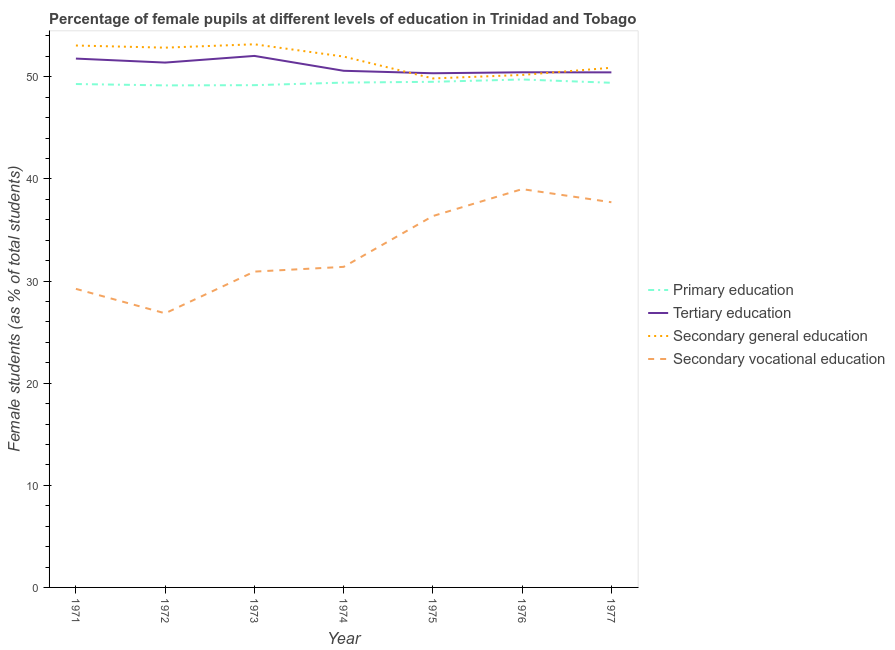Does the line corresponding to percentage of female students in primary education intersect with the line corresponding to percentage of female students in secondary education?
Provide a short and direct response. No. Is the number of lines equal to the number of legend labels?
Your response must be concise. Yes. What is the percentage of female students in secondary education in 1973?
Keep it short and to the point. 53.18. Across all years, what is the minimum percentage of female students in secondary vocational education?
Provide a short and direct response. 26.84. In which year was the percentage of female students in secondary vocational education maximum?
Make the answer very short. 1976. In which year was the percentage of female students in primary education minimum?
Give a very brief answer. 1972. What is the total percentage of female students in primary education in the graph?
Your response must be concise. 345.71. What is the difference between the percentage of female students in tertiary education in 1973 and that in 1977?
Your answer should be compact. 1.61. What is the difference between the percentage of female students in secondary vocational education in 1971 and the percentage of female students in tertiary education in 1974?
Your answer should be very brief. -21.35. What is the average percentage of female students in tertiary education per year?
Ensure brevity in your answer.  51. In the year 1977, what is the difference between the percentage of female students in tertiary education and percentage of female students in secondary vocational education?
Your answer should be very brief. 12.72. In how many years, is the percentage of female students in secondary education greater than 48 %?
Give a very brief answer. 7. What is the ratio of the percentage of female students in secondary vocational education in 1972 to that in 1977?
Make the answer very short. 0.71. What is the difference between the highest and the second highest percentage of female students in tertiary education?
Provide a short and direct response. 0.26. What is the difference between the highest and the lowest percentage of female students in tertiary education?
Your answer should be compact. 1.7. Does the percentage of female students in primary education monotonically increase over the years?
Your response must be concise. No. Is the percentage of female students in secondary vocational education strictly greater than the percentage of female students in tertiary education over the years?
Give a very brief answer. No. How many lines are there?
Offer a terse response. 4. How many years are there in the graph?
Your answer should be very brief. 7. What is the difference between two consecutive major ticks on the Y-axis?
Keep it short and to the point. 10. Are the values on the major ticks of Y-axis written in scientific E-notation?
Make the answer very short. No. Where does the legend appear in the graph?
Make the answer very short. Center right. What is the title of the graph?
Your response must be concise. Percentage of female pupils at different levels of education in Trinidad and Tobago. What is the label or title of the Y-axis?
Ensure brevity in your answer.  Female students (as % of total students). What is the Female students (as % of total students) in Primary education in 1971?
Offer a very short reply. 49.29. What is the Female students (as % of total students) of Tertiary education in 1971?
Keep it short and to the point. 51.78. What is the Female students (as % of total students) of Secondary general education in 1971?
Offer a very short reply. 53.06. What is the Female students (as % of total students) of Secondary vocational education in 1971?
Your response must be concise. 29.23. What is the Female students (as % of total students) of Primary education in 1972?
Offer a terse response. 49.16. What is the Female students (as % of total students) in Tertiary education in 1972?
Your answer should be very brief. 51.39. What is the Female students (as % of total students) of Secondary general education in 1972?
Keep it short and to the point. 52.85. What is the Female students (as % of total students) of Secondary vocational education in 1972?
Your answer should be compact. 26.84. What is the Female students (as % of total students) of Primary education in 1973?
Offer a terse response. 49.18. What is the Female students (as % of total students) in Tertiary education in 1973?
Your answer should be compact. 52.04. What is the Female students (as % of total students) of Secondary general education in 1973?
Provide a short and direct response. 53.18. What is the Female students (as % of total students) in Secondary vocational education in 1973?
Provide a short and direct response. 30.92. What is the Female students (as % of total students) of Primary education in 1974?
Make the answer very short. 49.43. What is the Female students (as % of total students) in Tertiary education in 1974?
Offer a very short reply. 50.59. What is the Female students (as % of total students) of Secondary general education in 1974?
Offer a very short reply. 51.98. What is the Female students (as % of total students) in Secondary vocational education in 1974?
Keep it short and to the point. 31.39. What is the Female students (as % of total students) in Primary education in 1975?
Provide a succinct answer. 49.51. What is the Female students (as % of total students) in Tertiary education in 1975?
Ensure brevity in your answer.  50.34. What is the Female students (as % of total students) in Secondary general education in 1975?
Give a very brief answer. 49.84. What is the Female students (as % of total students) in Secondary vocational education in 1975?
Make the answer very short. 36.36. What is the Female students (as % of total students) in Primary education in 1976?
Offer a terse response. 49.74. What is the Female students (as % of total students) of Tertiary education in 1976?
Your answer should be compact. 50.44. What is the Female students (as % of total students) in Secondary general education in 1976?
Offer a very short reply. 50.18. What is the Female students (as % of total students) in Secondary vocational education in 1976?
Ensure brevity in your answer.  39. What is the Female students (as % of total students) in Primary education in 1977?
Provide a short and direct response. 49.41. What is the Female students (as % of total students) in Tertiary education in 1977?
Give a very brief answer. 50.43. What is the Female students (as % of total students) of Secondary general education in 1977?
Provide a short and direct response. 50.88. What is the Female students (as % of total students) in Secondary vocational education in 1977?
Provide a succinct answer. 37.72. Across all years, what is the maximum Female students (as % of total students) in Primary education?
Offer a terse response. 49.74. Across all years, what is the maximum Female students (as % of total students) in Tertiary education?
Offer a terse response. 52.04. Across all years, what is the maximum Female students (as % of total students) of Secondary general education?
Your answer should be very brief. 53.18. Across all years, what is the maximum Female students (as % of total students) in Secondary vocational education?
Your answer should be very brief. 39. Across all years, what is the minimum Female students (as % of total students) in Primary education?
Your response must be concise. 49.16. Across all years, what is the minimum Female students (as % of total students) of Tertiary education?
Offer a terse response. 50.34. Across all years, what is the minimum Female students (as % of total students) of Secondary general education?
Your answer should be very brief. 49.84. Across all years, what is the minimum Female students (as % of total students) of Secondary vocational education?
Ensure brevity in your answer.  26.84. What is the total Female students (as % of total students) of Primary education in the graph?
Keep it short and to the point. 345.71. What is the total Female students (as % of total students) in Tertiary education in the graph?
Your answer should be very brief. 357.02. What is the total Female students (as % of total students) of Secondary general education in the graph?
Provide a succinct answer. 361.97. What is the total Female students (as % of total students) of Secondary vocational education in the graph?
Offer a terse response. 231.46. What is the difference between the Female students (as % of total students) in Primary education in 1971 and that in 1972?
Give a very brief answer. 0.13. What is the difference between the Female students (as % of total students) of Tertiary education in 1971 and that in 1972?
Your answer should be compact. 0.39. What is the difference between the Female students (as % of total students) in Secondary general education in 1971 and that in 1972?
Provide a succinct answer. 0.21. What is the difference between the Female students (as % of total students) in Secondary vocational education in 1971 and that in 1972?
Give a very brief answer. 2.39. What is the difference between the Female students (as % of total students) of Primary education in 1971 and that in 1973?
Provide a short and direct response. 0.11. What is the difference between the Female students (as % of total students) of Tertiary education in 1971 and that in 1973?
Make the answer very short. -0.26. What is the difference between the Female students (as % of total students) in Secondary general education in 1971 and that in 1973?
Make the answer very short. -0.12. What is the difference between the Female students (as % of total students) in Secondary vocational education in 1971 and that in 1973?
Give a very brief answer. -1.69. What is the difference between the Female students (as % of total students) of Primary education in 1971 and that in 1974?
Your answer should be very brief. -0.14. What is the difference between the Female students (as % of total students) in Tertiary education in 1971 and that in 1974?
Give a very brief answer. 1.19. What is the difference between the Female students (as % of total students) of Secondary general education in 1971 and that in 1974?
Your response must be concise. 1.08. What is the difference between the Female students (as % of total students) of Secondary vocational education in 1971 and that in 1974?
Give a very brief answer. -2.15. What is the difference between the Female students (as % of total students) in Primary education in 1971 and that in 1975?
Make the answer very short. -0.22. What is the difference between the Female students (as % of total students) of Tertiary education in 1971 and that in 1975?
Provide a short and direct response. 1.44. What is the difference between the Female students (as % of total students) of Secondary general education in 1971 and that in 1975?
Offer a very short reply. 3.22. What is the difference between the Female students (as % of total students) of Secondary vocational education in 1971 and that in 1975?
Provide a short and direct response. -7.13. What is the difference between the Female students (as % of total students) of Primary education in 1971 and that in 1976?
Your response must be concise. -0.45. What is the difference between the Female students (as % of total students) in Tertiary education in 1971 and that in 1976?
Offer a very short reply. 1.34. What is the difference between the Female students (as % of total students) of Secondary general education in 1971 and that in 1976?
Offer a terse response. 2.88. What is the difference between the Female students (as % of total students) of Secondary vocational education in 1971 and that in 1976?
Offer a terse response. -9.77. What is the difference between the Female students (as % of total students) of Primary education in 1971 and that in 1977?
Provide a short and direct response. -0.12. What is the difference between the Female students (as % of total students) of Tertiary education in 1971 and that in 1977?
Offer a terse response. 1.35. What is the difference between the Female students (as % of total students) in Secondary general education in 1971 and that in 1977?
Provide a succinct answer. 2.18. What is the difference between the Female students (as % of total students) in Secondary vocational education in 1971 and that in 1977?
Keep it short and to the point. -8.48. What is the difference between the Female students (as % of total students) in Primary education in 1972 and that in 1973?
Give a very brief answer. -0.02. What is the difference between the Female students (as % of total students) of Tertiary education in 1972 and that in 1973?
Keep it short and to the point. -0.65. What is the difference between the Female students (as % of total students) in Secondary general education in 1972 and that in 1973?
Make the answer very short. -0.33. What is the difference between the Female students (as % of total students) in Secondary vocational education in 1972 and that in 1973?
Make the answer very short. -4.08. What is the difference between the Female students (as % of total students) of Primary education in 1972 and that in 1974?
Keep it short and to the point. -0.27. What is the difference between the Female students (as % of total students) of Tertiary education in 1972 and that in 1974?
Your answer should be compact. 0.8. What is the difference between the Female students (as % of total students) of Secondary general education in 1972 and that in 1974?
Your answer should be very brief. 0.87. What is the difference between the Female students (as % of total students) in Secondary vocational education in 1972 and that in 1974?
Ensure brevity in your answer.  -4.55. What is the difference between the Female students (as % of total students) of Primary education in 1972 and that in 1975?
Give a very brief answer. -0.35. What is the difference between the Female students (as % of total students) of Tertiary education in 1972 and that in 1975?
Make the answer very short. 1.05. What is the difference between the Female students (as % of total students) in Secondary general education in 1972 and that in 1975?
Offer a very short reply. 3.01. What is the difference between the Female students (as % of total students) in Secondary vocational education in 1972 and that in 1975?
Your answer should be very brief. -9.52. What is the difference between the Female students (as % of total students) of Primary education in 1972 and that in 1976?
Provide a short and direct response. -0.58. What is the difference between the Female students (as % of total students) in Tertiary education in 1972 and that in 1976?
Provide a short and direct response. 0.95. What is the difference between the Female students (as % of total students) in Secondary general education in 1972 and that in 1976?
Give a very brief answer. 2.67. What is the difference between the Female students (as % of total students) in Secondary vocational education in 1972 and that in 1976?
Your answer should be compact. -12.16. What is the difference between the Female students (as % of total students) of Primary education in 1972 and that in 1977?
Make the answer very short. -0.25. What is the difference between the Female students (as % of total students) of Tertiary education in 1972 and that in 1977?
Make the answer very short. 0.96. What is the difference between the Female students (as % of total students) of Secondary general education in 1972 and that in 1977?
Provide a short and direct response. 1.97. What is the difference between the Female students (as % of total students) in Secondary vocational education in 1972 and that in 1977?
Keep it short and to the point. -10.88. What is the difference between the Female students (as % of total students) in Primary education in 1973 and that in 1974?
Provide a succinct answer. -0.25. What is the difference between the Female students (as % of total students) of Tertiary education in 1973 and that in 1974?
Offer a very short reply. 1.46. What is the difference between the Female students (as % of total students) in Secondary general education in 1973 and that in 1974?
Provide a short and direct response. 1.2. What is the difference between the Female students (as % of total students) in Secondary vocational education in 1973 and that in 1974?
Provide a short and direct response. -0.46. What is the difference between the Female students (as % of total students) in Primary education in 1973 and that in 1975?
Ensure brevity in your answer.  -0.33. What is the difference between the Female students (as % of total students) of Tertiary education in 1973 and that in 1975?
Make the answer very short. 1.7. What is the difference between the Female students (as % of total students) of Secondary general education in 1973 and that in 1975?
Your answer should be very brief. 3.34. What is the difference between the Female students (as % of total students) in Secondary vocational education in 1973 and that in 1975?
Offer a very short reply. -5.44. What is the difference between the Female students (as % of total students) of Primary education in 1973 and that in 1976?
Ensure brevity in your answer.  -0.56. What is the difference between the Female students (as % of total students) of Tertiary education in 1973 and that in 1976?
Ensure brevity in your answer.  1.6. What is the difference between the Female students (as % of total students) in Secondary general education in 1973 and that in 1976?
Ensure brevity in your answer.  3. What is the difference between the Female students (as % of total students) in Secondary vocational education in 1973 and that in 1976?
Offer a very short reply. -8.08. What is the difference between the Female students (as % of total students) in Primary education in 1973 and that in 1977?
Offer a very short reply. -0.23. What is the difference between the Female students (as % of total students) of Tertiary education in 1973 and that in 1977?
Offer a very short reply. 1.61. What is the difference between the Female students (as % of total students) of Secondary general education in 1973 and that in 1977?
Your answer should be very brief. 2.3. What is the difference between the Female students (as % of total students) in Secondary vocational education in 1973 and that in 1977?
Offer a terse response. -6.79. What is the difference between the Female students (as % of total students) in Primary education in 1974 and that in 1975?
Your answer should be compact. -0.08. What is the difference between the Female students (as % of total students) in Tertiary education in 1974 and that in 1975?
Your answer should be very brief. 0.24. What is the difference between the Female students (as % of total students) of Secondary general education in 1974 and that in 1975?
Your answer should be very brief. 2.14. What is the difference between the Female students (as % of total students) of Secondary vocational education in 1974 and that in 1975?
Keep it short and to the point. -4.98. What is the difference between the Female students (as % of total students) in Primary education in 1974 and that in 1976?
Ensure brevity in your answer.  -0.31. What is the difference between the Female students (as % of total students) of Tertiary education in 1974 and that in 1976?
Your answer should be compact. 0.15. What is the difference between the Female students (as % of total students) in Secondary general education in 1974 and that in 1976?
Your response must be concise. 1.8. What is the difference between the Female students (as % of total students) of Secondary vocational education in 1974 and that in 1976?
Make the answer very short. -7.61. What is the difference between the Female students (as % of total students) in Primary education in 1974 and that in 1977?
Make the answer very short. 0.02. What is the difference between the Female students (as % of total students) of Tertiary education in 1974 and that in 1977?
Provide a succinct answer. 0.15. What is the difference between the Female students (as % of total students) of Secondary general education in 1974 and that in 1977?
Your answer should be compact. 1.09. What is the difference between the Female students (as % of total students) of Secondary vocational education in 1974 and that in 1977?
Your answer should be compact. -6.33. What is the difference between the Female students (as % of total students) of Primary education in 1975 and that in 1976?
Your response must be concise. -0.23. What is the difference between the Female students (as % of total students) in Tertiary education in 1975 and that in 1976?
Ensure brevity in your answer.  -0.09. What is the difference between the Female students (as % of total students) of Secondary general education in 1975 and that in 1976?
Offer a very short reply. -0.34. What is the difference between the Female students (as % of total students) of Secondary vocational education in 1975 and that in 1976?
Provide a succinct answer. -2.64. What is the difference between the Female students (as % of total students) in Primary education in 1975 and that in 1977?
Your response must be concise. 0.1. What is the difference between the Female students (as % of total students) of Tertiary education in 1975 and that in 1977?
Your answer should be very brief. -0.09. What is the difference between the Female students (as % of total students) in Secondary general education in 1975 and that in 1977?
Provide a succinct answer. -1.05. What is the difference between the Female students (as % of total students) of Secondary vocational education in 1975 and that in 1977?
Make the answer very short. -1.35. What is the difference between the Female students (as % of total students) of Primary education in 1976 and that in 1977?
Your answer should be very brief. 0.32. What is the difference between the Female students (as % of total students) of Tertiary education in 1976 and that in 1977?
Provide a succinct answer. 0.01. What is the difference between the Female students (as % of total students) of Secondary general education in 1976 and that in 1977?
Keep it short and to the point. -0.71. What is the difference between the Female students (as % of total students) of Secondary vocational education in 1976 and that in 1977?
Ensure brevity in your answer.  1.28. What is the difference between the Female students (as % of total students) of Primary education in 1971 and the Female students (as % of total students) of Tertiary education in 1972?
Offer a terse response. -2.1. What is the difference between the Female students (as % of total students) in Primary education in 1971 and the Female students (as % of total students) in Secondary general education in 1972?
Give a very brief answer. -3.56. What is the difference between the Female students (as % of total students) in Primary education in 1971 and the Female students (as % of total students) in Secondary vocational education in 1972?
Your answer should be compact. 22.45. What is the difference between the Female students (as % of total students) in Tertiary education in 1971 and the Female students (as % of total students) in Secondary general education in 1972?
Offer a very short reply. -1.07. What is the difference between the Female students (as % of total students) of Tertiary education in 1971 and the Female students (as % of total students) of Secondary vocational education in 1972?
Provide a short and direct response. 24.94. What is the difference between the Female students (as % of total students) in Secondary general education in 1971 and the Female students (as % of total students) in Secondary vocational education in 1972?
Provide a short and direct response. 26.22. What is the difference between the Female students (as % of total students) in Primary education in 1971 and the Female students (as % of total students) in Tertiary education in 1973?
Offer a very short reply. -2.75. What is the difference between the Female students (as % of total students) in Primary education in 1971 and the Female students (as % of total students) in Secondary general education in 1973?
Your response must be concise. -3.89. What is the difference between the Female students (as % of total students) in Primary education in 1971 and the Female students (as % of total students) in Secondary vocational education in 1973?
Keep it short and to the point. 18.37. What is the difference between the Female students (as % of total students) of Tertiary education in 1971 and the Female students (as % of total students) of Secondary general education in 1973?
Offer a terse response. -1.4. What is the difference between the Female students (as % of total students) of Tertiary education in 1971 and the Female students (as % of total students) of Secondary vocational education in 1973?
Provide a succinct answer. 20.86. What is the difference between the Female students (as % of total students) of Secondary general education in 1971 and the Female students (as % of total students) of Secondary vocational education in 1973?
Offer a very short reply. 22.14. What is the difference between the Female students (as % of total students) in Primary education in 1971 and the Female students (as % of total students) in Tertiary education in 1974?
Provide a succinct answer. -1.3. What is the difference between the Female students (as % of total students) of Primary education in 1971 and the Female students (as % of total students) of Secondary general education in 1974?
Make the answer very short. -2.69. What is the difference between the Female students (as % of total students) in Primary education in 1971 and the Female students (as % of total students) in Secondary vocational education in 1974?
Your answer should be compact. 17.9. What is the difference between the Female students (as % of total students) of Tertiary education in 1971 and the Female students (as % of total students) of Secondary general education in 1974?
Your answer should be very brief. -0.2. What is the difference between the Female students (as % of total students) in Tertiary education in 1971 and the Female students (as % of total students) in Secondary vocational education in 1974?
Your response must be concise. 20.39. What is the difference between the Female students (as % of total students) of Secondary general education in 1971 and the Female students (as % of total students) of Secondary vocational education in 1974?
Your response must be concise. 21.67. What is the difference between the Female students (as % of total students) of Primary education in 1971 and the Female students (as % of total students) of Tertiary education in 1975?
Offer a terse response. -1.05. What is the difference between the Female students (as % of total students) in Primary education in 1971 and the Female students (as % of total students) in Secondary general education in 1975?
Keep it short and to the point. -0.55. What is the difference between the Female students (as % of total students) in Primary education in 1971 and the Female students (as % of total students) in Secondary vocational education in 1975?
Offer a terse response. 12.93. What is the difference between the Female students (as % of total students) in Tertiary education in 1971 and the Female students (as % of total students) in Secondary general education in 1975?
Ensure brevity in your answer.  1.94. What is the difference between the Female students (as % of total students) of Tertiary education in 1971 and the Female students (as % of total students) of Secondary vocational education in 1975?
Provide a succinct answer. 15.42. What is the difference between the Female students (as % of total students) of Secondary general education in 1971 and the Female students (as % of total students) of Secondary vocational education in 1975?
Ensure brevity in your answer.  16.7. What is the difference between the Female students (as % of total students) of Primary education in 1971 and the Female students (as % of total students) of Tertiary education in 1976?
Provide a short and direct response. -1.15. What is the difference between the Female students (as % of total students) in Primary education in 1971 and the Female students (as % of total students) in Secondary general education in 1976?
Keep it short and to the point. -0.89. What is the difference between the Female students (as % of total students) in Primary education in 1971 and the Female students (as % of total students) in Secondary vocational education in 1976?
Give a very brief answer. 10.29. What is the difference between the Female students (as % of total students) in Tertiary education in 1971 and the Female students (as % of total students) in Secondary general education in 1976?
Keep it short and to the point. 1.6. What is the difference between the Female students (as % of total students) of Tertiary education in 1971 and the Female students (as % of total students) of Secondary vocational education in 1976?
Give a very brief answer. 12.78. What is the difference between the Female students (as % of total students) in Secondary general education in 1971 and the Female students (as % of total students) in Secondary vocational education in 1976?
Offer a terse response. 14.06. What is the difference between the Female students (as % of total students) of Primary education in 1971 and the Female students (as % of total students) of Tertiary education in 1977?
Your answer should be compact. -1.14. What is the difference between the Female students (as % of total students) in Primary education in 1971 and the Female students (as % of total students) in Secondary general education in 1977?
Your answer should be compact. -1.59. What is the difference between the Female students (as % of total students) of Primary education in 1971 and the Female students (as % of total students) of Secondary vocational education in 1977?
Make the answer very short. 11.57. What is the difference between the Female students (as % of total students) in Tertiary education in 1971 and the Female students (as % of total students) in Secondary general education in 1977?
Offer a terse response. 0.9. What is the difference between the Female students (as % of total students) in Tertiary education in 1971 and the Female students (as % of total students) in Secondary vocational education in 1977?
Offer a terse response. 14.06. What is the difference between the Female students (as % of total students) of Secondary general education in 1971 and the Female students (as % of total students) of Secondary vocational education in 1977?
Offer a terse response. 15.35. What is the difference between the Female students (as % of total students) in Primary education in 1972 and the Female students (as % of total students) in Tertiary education in 1973?
Your answer should be very brief. -2.89. What is the difference between the Female students (as % of total students) of Primary education in 1972 and the Female students (as % of total students) of Secondary general education in 1973?
Offer a very short reply. -4.03. What is the difference between the Female students (as % of total students) of Primary education in 1972 and the Female students (as % of total students) of Secondary vocational education in 1973?
Make the answer very short. 18.23. What is the difference between the Female students (as % of total students) of Tertiary education in 1972 and the Female students (as % of total students) of Secondary general education in 1973?
Your answer should be very brief. -1.79. What is the difference between the Female students (as % of total students) of Tertiary education in 1972 and the Female students (as % of total students) of Secondary vocational education in 1973?
Your response must be concise. 20.47. What is the difference between the Female students (as % of total students) of Secondary general education in 1972 and the Female students (as % of total students) of Secondary vocational education in 1973?
Ensure brevity in your answer.  21.93. What is the difference between the Female students (as % of total students) in Primary education in 1972 and the Female students (as % of total students) in Tertiary education in 1974?
Offer a very short reply. -1.43. What is the difference between the Female students (as % of total students) of Primary education in 1972 and the Female students (as % of total students) of Secondary general education in 1974?
Your answer should be very brief. -2.82. What is the difference between the Female students (as % of total students) of Primary education in 1972 and the Female students (as % of total students) of Secondary vocational education in 1974?
Offer a terse response. 17.77. What is the difference between the Female students (as % of total students) of Tertiary education in 1972 and the Female students (as % of total students) of Secondary general education in 1974?
Your answer should be very brief. -0.59. What is the difference between the Female students (as % of total students) of Tertiary education in 1972 and the Female students (as % of total students) of Secondary vocational education in 1974?
Your response must be concise. 20. What is the difference between the Female students (as % of total students) of Secondary general education in 1972 and the Female students (as % of total students) of Secondary vocational education in 1974?
Your answer should be very brief. 21.46. What is the difference between the Female students (as % of total students) in Primary education in 1972 and the Female students (as % of total students) in Tertiary education in 1975?
Ensure brevity in your answer.  -1.19. What is the difference between the Female students (as % of total students) of Primary education in 1972 and the Female students (as % of total students) of Secondary general education in 1975?
Your answer should be compact. -0.68. What is the difference between the Female students (as % of total students) in Primary education in 1972 and the Female students (as % of total students) in Secondary vocational education in 1975?
Make the answer very short. 12.79. What is the difference between the Female students (as % of total students) of Tertiary education in 1972 and the Female students (as % of total students) of Secondary general education in 1975?
Make the answer very short. 1.55. What is the difference between the Female students (as % of total students) in Tertiary education in 1972 and the Female students (as % of total students) in Secondary vocational education in 1975?
Provide a short and direct response. 15.03. What is the difference between the Female students (as % of total students) of Secondary general education in 1972 and the Female students (as % of total students) of Secondary vocational education in 1975?
Your answer should be very brief. 16.49. What is the difference between the Female students (as % of total students) in Primary education in 1972 and the Female students (as % of total students) in Tertiary education in 1976?
Give a very brief answer. -1.28. What is the difference between the Female students (as % of total students) in Primary education in 1972 and the Female students (as % of total students) in Secondary general education in 1976?
Ensure brevity in your answer.  -1.02. What is the difference between the Female students (as % of total students) in Primary education in 1972 and the Female students (as % of total students) in Secondary vocational education in 1976?
Offer a terse response. 10.16. What is the difference between the Female students (as % of total students) of Tertiary education in 1972 and the Female students (as % of total students) of Secondary general education in 1976?
Offer a very short reply. 1.21. What is the difference between the Female students (as % of total students) of Tertiary education in 1972 and the Female students (as % of total students) of Secondary vocational education in 1976?
Your answer should be very brief. 12.39. What is the difference between the Female students (as % of total students) in Secondary general education in 1972 and the Female students (as % of total students) in Secondary vocational education in 1976?
Provide a short and direct response. 13.85. What is the difference between the Female students (as % of total students) of Primary education in 1972 and the Female students (as % of total students) of Tertiary education in 1977?
Your response must be concise. -1.28. What is the difference between the Female students (as % of total students) in Primary education in 1972 and the Female students (as % of total students) in Secondary general education in 1977?
Your response must be concise. -1.73. What is the difference between the Female students (as % of total students) in Primary education in 1972 and the Female students (as % of total students) in Secondary vocational education in 1977?
Offer a very short reply. 11.44. What is the difference between the Female students (as % of total students) in Tertiary education in 1972 and the Female students (as % of total students) in Secondary general education in 1977?
Make the answer very short. 0.51. What is the difference between the Female students (as % of total students) in Tertiary education in 1972 and the Female students (as % of total students) in Secondary vocational education in 1977?
Provide a succinct answer. 13.67. What is the difference between the Female students (as % of total students) of Secondary general education in 1972 and the Female students (as % of total students) of Secondary vocational education in 1977?
Ensure brevity in your answer.  15.13. What is the difference between the Female students (as % of total students) of Primary education in 1973 and the Female students (as % of total students) of Tertiary education in 1974?
Give a very brief answer. -1.41. What is the difference between the Female students (as % of total students) in Primary education in 1973 and the Female students (as % of total students) in Secondary general education in 1974?
Provide a succinct answer. -2.8. What is the difference between the Female students (as % of total students) in Primary education in 1973 and the Female students (as % of total students) in Secondary vocational education in 1974?
Keep it short and to the point. 17.79. What is the difference between the Female students (as % of total students) in Tertiary education in 1973 and the Female students (as % of total students) in Secondary general education in 1974?
Ensure brevity in your answer.  0.06. What is the difference between the Female students (as % of total students) of Tertiary education in 1973 and the Female students (as % of total students) of Secondary vocational education in 1974?
Ensure brevity in your answer.  20.66. What is the difference between the Female students (as % of total students) in Secondary general education in 1973 and the Female students (as % of total students) in Secondary vocational education in 1974?
Your answer should be very brief. 21.79. What is the difference between the Female students (as % of total students) of Primary education in 1973 and the Female students (as % of total students) of Tertiary education in 1975?
Your response must be concise. -1.17. What is the difference between the Female students (as % of total students) in Primary education in 1973 and the Female students (as % of total students) in Secondary general education in 1975?
Give a very brief answer. -0.66. What is the difference between the Female students (as % of total students) in Primary education in 1973 and the Female students (as % of total students) in Secondary vocational education in 1975?
Offer a very short reply. 12.81. What is the difference between the Female students (as % of total students) in Tertiary education in 1973 and the Female students (as % of total students) in Secondary general education in 1975?
Offer a very short reply. 2.2. What is the difference between the Female students (as % of total students) in Tertiary education in 1973 and the Female students (as % of total students) in Secondary vocational education in 1975?
Give a very brief answer. 15.68. What is the difference between the Female students (as % of total students) in Secondary general education in 1973 and the Female students (as % of total students) in Secondary vocational education in 1975?
Provide a succinct answer. 16.82. What is the difference between the Female students (as % of total students) in Primary education in 1973 and the Female students (as % of total students) in Tertiary education in 1976?
Offer a terse response. -1.26. What is the difference between the Female students (as % of total students) in Primary education in 1973 and the Female students (as % of total students) in Secondary general education in 1976?
Make the answer very short. -1. What is the difference between the Female students (as % of total students) of Primary education in 1973 and the Female students (as % of total students) of Secondary vocational education in 1976?
Offer a terse response. 10.18. What is the difference between the Female students (as % of total students) in Tertiary education in 1973 and the Female students (as % of total students) in Secondary general education in 1976?
Ensure brevity in your answer.  1.86. What is the difference between the Female students (as % of total students) in Tertiary education in 1973 and the Female students (as % of total students) in Secondary vocational education in 1976?
Offer a terse response. 13.04. What is the difference between the Female students (as % of total students) in Secondary general education in 1973 and the Female students (as % of total students) in Secondary vocational education in 1976?
Provide a succinct answer. 14.18. What is the difference between the Female students (as % of total students) in Primary education in 1973 and the Female students (as % of total students) in Tertiary education in 1977?
Provide a short and direct response. -1.26. What is the difference between the Female students (as % of total students) of Primary education in 1973 and the Female students (as % of total students) of Secondary general education in 1977?
Provide a succinct answer. -1.71. What is the difference between the Female students (as % of total students) of Primary education in 1973 and the Female students (as % of total students) of Secondary vocational education in 1977?
Keep it short and to the point. 11.46. What is the difference between the Female students (as % of total students) in Tertiary education in 1973 and the Female students (as % of total students) in Secondary general education in 1977?
Provide a short and direct response. 1.16. What is the difference between the Female students (as % of total students) of Tertiary education in 1973 and the Female students (as % of total students) of Secondary vocational education in 1977?
Ensure brevity in your answer.  14.33. What is the difference between the Female students (as % of total students) of Secondary general education in 1973 and the Female students (as % of total students) of Secondary vocational education in 1977?
Your response must be concise. 15.47. What is the difference between the Female students (as % of total students) of Primary education in 1974 and the Female students (as % of total students) of Tertiary education in 1975?
Make the answer very short. -0.92. What is the difference between the Female students (as % of total students) in Primary education in 1974 and the Female students (as % of total students) in Secondary general education in 1975?
Offer a very short reply. -0.41. What is the difference between the Female students (as % of total students) in Primary education in 1974 and the Female students (as % of total students) in Secondary vocational education in 1975?
Your response must be concise. 13.07. What is the difference between the Female students (as % of total students) in Tertiary education in 1974 and the Female students (as % of total students) in Secondary general education in 1975?
Offer a very short reply. 0.75. What is the difference between the Female students (as % of total students) of Tertiary education in 1974 and the Female students (as % of total students) of Secondary vocational education in 1975?
Offer a terse response. 14.22. What is the difference between the Female students (as % of total students) in Secondary general education in 1974 and the Female students (as % of total students) in Secondary vocational education in 1975?
Give a very brief answer. 15.62. What is the difference between the Female students (as % of total students) of Primary education in 1974 and the Female students (as % of total students) of Tertiary education in 1976?
Your response must be concise. -1.01. What is the difference between the Female students (as % of total students) of Primary education in 1974 and the Female students (as % of total students) of Secondary general education in 1976?
Your response must be concise. -0.75. What is the difference between the Female students (as % of total students) in Primary education in 1974 and the Female students (as % of total students) in Secondary vocational education in 1976?
Your answer should be very brief. 10.43. What is the difference between the Female students (as % of total students) in Tertiary education in 1974 and the Female students (as % of total students) in Secondary general education in 1976?
Keep it short and to the point. 0.41. What is the difference between the Female students (as % of total students) of Tertiary education in 1974 and the Female students (as % of total students) of Secondary vocational education in 1976?
Ensure brevity in your answer.  11.59. What is the difference between the Female students (as % of total students) of Secondary general education in 1974 and the Female students (as % of total students) of Secondary vocational education in 1976?
Give a very brief answer. 12.98. What is the difference between the Female students (as % of total students) of Primary education in 1974 and the Female students (as % of total students) of Tertiary education in 1977?
Offer a very short reply. -1. What is the difference between the Female students (as % of total students) of Primary education in 1974 and the Female students (as % of total students) of Secondary general education in 1977?
Make the answer very short. -1.46. What is the difference between the Female students (as % of total students) of Primary education in 1974 and the Female students (as % of total students) of Secondary vocational education in 1977?
Keep it short and to the point. 11.71. What is the difference between the Female students (as % of total students) of Tertiary education in 1974 and the Female students (as % of total students) of Secondary general education in 1977?
Offer a very short reply. -0.3. What is the difference between the Female students (as % of total students) in Tertiary education in 1974 and the Female students (as % of total students) in Secondary vocational education in 1977?
Your response must be concise. 12.87. What is the difference between the Female students (as % of total students) in Secondary general education in 1974 and the Female students (as % of total students) in Secondary vocational education in 1977?
Ensure brevity in your answer.  14.26. What is the difference between the Female students (as % of total students) in Primary education in 1975 and the Female students (as % of total students) in Tertiary education in 1976?
Provide a succinct answer. -0.93. What is the difference between the Female students (as % of total students) in Primary education in 1975 and the Female students (as % of total students) in Secondary general education in 1976?
Make the answer very short. -0.67. What is the difference between the Female students (as % of total students) in Primary education in 1975 and the Female students (as % of total students) in Secondary vocational education in 1976?
Make the answer very short. 10.51. What is the difference between the Female students (as % of total students) in Tertiary education in 1975 and the Female students (as % of total students) in Secondary general education in 1976?
Provide a short and direct response. 0.17. What is the difference between the Female students (as % of total students) of Tertiary education in 1975 and the Female students (as % of total students) of Secondary vocational education in 1976?
Your answer should be very brief. 11.35. What is the difference between the Female students (as % of total students) in Secondary general education in 1975 and the Female students (as % of total students) in Secondary vocational education in 1976?
Offer a very short reply. 10.84. What is the difference between the Female students (as % of total students) in Primary education in 1975 and the Female students (as % of total students) in Tertiary education in 1977?
Ensure brevity in your answer.  -0.92. What is the difference between the Female students (as % of total students) of Primary education in 1975 and the Female students (as % of total students) of Secondary general education in 1977?
Give a very brief answer. -1.38. What is the difference between the Female students (as % of total students) of Primary education in 1975 and the Female students (as % of total students) of Secondary vocational education in 1977?
Your answer should be very brief. 11.79. What is the difference between the Female students (as % of total students) in Tertiary education in 1975 and the Female students (as % of total students) in Secondary general education in 1977?
Make the answer very short. -0.54. What is the difference between the Female students (as % of total students) in Tertiary education in 1975 and the Female students (as % of total students) in Secondary vocational education in 1977?
Your answer should be compact. 12.63. What is the difference between the Female students (as % of total students) of Secondary general education in 1975 and the Female students (as % of total students) of Secondary vocational education in 1977?
Make the answer very short. 12.12. What is the difference between the Female students (as % of total students) of Primary education in 1976 and the Female students (as % of total students) of Tertiary education in 1977?
Your answer should be compact. -0.7. What is the difference between the Female students (as % of total students) in Primary education in 1976 and the Female students (as % of total students) in Secondary general education in 1977?
Give a very brief answer. -1.15. What is the difference between the Female students (as % of total students) in Primary education in 1976 and the Female students (as % of total students) in Secondary vocational education in 1977?
Provide a succinct answer. 12.02. What is the difference between the Female students (as % of total students) of Tertiary education in 1976 and the Female students (as % of total students) of Secondary general education in 1977?
Provide a succinct answer. -0.45. What is the difference between the Female students (as % of total students) of Tertiary education in 1976 and the Female students (as % of total students) of Secondary vocational education in 1977?
Offer a terse response. 12.72. What is the difference between the Female students (as % of total students) of Secondary general education in 1976 and the Female students (as % of total students) of Secondary vocational education in 1977?
Offer a terse response. 12.46. What is the average Female students (as % of total students) in Primary education per year?
Keep it short and to the point. 49.39. What is the average Female students (as % of total students) of Tertiary education per year?
Keep it short and to the point. 51. What is the average Female students (as % of total students) in Secondary general education per year?
Keep it short and to the point. 51.71. What is the average Female students (as % of total students) in Secondary vocational education per year?
Ensure brevity in your answer.  33.07. In the year 1971, what is the difference between the Female students (as % of total students) of Primary education and Female students (as % of total students) of Tertiary education?
Offer a very short reply. -2.49. In the year 1971, what is the difference between the Female students (as % of total students) in Primary education and Female students (as % of total students) in Secondary general education?
Give a very brief answer. -3.77. In the year 1971, what is the difference between the Female students (as % of total students) of Primary education and Female students (as % of total students) of Secondary vocational education?
Keep it short and to the point. 20.06. In the year 1971, what is the difference between the Female students (as % of total students) in Tertiary education and Female students (as % of total students) in Secondary general education?
Provide a short and direct response. -1.28. In the year 1971, what is the difference between the Female students (as % of total students) of Tertiary education and Female students (as % of total students) of Secondary vocational education?
Your response must be concise. 22.55. In the year 1971, what is the difference between the Female students (as % of total students) in Secondary general education and Female students (as % of total students) in Secondary vocational education?
Give a very brief answer. 23.83. In the year 1972, what is the difference between the Female students (as % of total students) of Primary education and Female students (as % of total students) of Tertiary education?
Provide a short and direct response. -2.23. In the year 1972, what is the difference between the Female students (as % of total students) in Primary education and Female students (as % of total students) in Secondary general education?
Your answer should be compact. -3.69. In the year 1972, what is the difference between the Female students (as % of total students) in Primary education and Female students (as % of total students) in Secondary vocational education?
Your answer should be compact. 22.32. In the year 1972, what is the difference between the Female students (as % of total students) in Tertiary education and Female students (as % of total students) in Secondary general education?
Your answer should be very brief. -1.46. In the year 1972, what is the difference between the Female students (as % of total students) in Tertiary education and Female students (as % of total students) in Secondary vocational education?
Your answer should be very brief. 24.55. In the year 1972, what is the difference between the Female students (as % of total students) of Secondary general education and Female students (as % of total students) of Secondary vocational education?
Keep it short and to the point. 26.01. In the year 1973, what is the difference between the Female students (as % of total students) in Primary education and Female students (as % of total students) in Tertiary education?
Offer a terse response. -2.87. In the year 1973, what is the difference between the Female students (as % of total students) in Primary education and Female students (as % of total students) in Secondary general education?
Your response must be concise. -4. In the year 1973, what is the difference between the Female students (as % of total students) of Primary education and Female students (as % of total students) of Secondary vocational education?
Offer a terse response. 18.25. In the year 1973, what is the difference between the Female students (as % of total students) of Tertiary education and Female students (as % of total students) of Secondary general education?
Make the answer very short. -1.14. In the year 1973, what is the difference between the Female students (as % of total students) of Tertiary education and Female students (as % of total students) of Secondary vocational education?
Ensure brevity in your answer.  21.12. In the year 1973, what is the difference between the Female students (as % of total students) of Secondary general education and Female students (as % of total students) of Secondary vocational education?
Keep it short and to the point. 22.26. In the year 1974, what is the difference between the Female students (as % of total students) in Primary education and Female students (as % of total students) in Tertiary education?
Provide a succinct answer. -1.16. In the year 1974, what is the difference between the Female students (as % of total students) of Primary education and Female students (as % of total students) of Secondary general education?
Provide a succinct answer. -2.55. In the year 1974, what is the difference between the Female students (as % of total students) of Primary education and Female students (as % of total students) of Secondary vocational education?
Your response must be concise. 18.04. In the year 1974, what is the difference between the Female students (as % of total students) of Tertiary education and Female students (as % of total students) of Secondary general education?
Your answer should be compact. -1.39. In the year 1974, what is the difference between the Female students (as % of total students) of Tertiary education and Female students (as % of total students) of Secondary vocational education?
Your response must be concise. 19.2. In the year 1974, what is the difference between the Female students (as % of total students) in Secondary general education and Female students (as % of total students) in Secondary vocational education?
Provide a short and direct response. 20.59. In the year 1975, what is the difference between the Female students (as % of total students) in Primary education and Female students (as % of total students) in Tertiary education?
Provide a short and direct response. -0.84. In the year 1975, what is the difference between the Female students (as % of total students) of Primary education and Female students (as % of total students) of Secondary general education?
Make the answer very short. -0.33. In the year 1975, what is the difference between the Female students (as % of total students) in Primary education and Female students (as % of total students) in Secondary vocational education?
Your answer should be compact. 13.14. In the year 1975, what is the difference between the Female students (as % of total students) in Tertiary education and Female students (as % of total students) in Secondary general education?
Offer a very short reply. 0.51. In the year 1975, what is the difference between the Female students (as % of total students) of Tertiary education and Female students (as % of total students) of Secondary vocational education?
Your answer should be very brief. 13.98. In the year 1975, what is the difference between the Female students (as % of total students) in Secondary general education and Female students (as % of total students) in Secondary vocational education?
Ensure brevity in your answer.  13.47. In the year 1976, what is the difference between the Female students (as % of total students) in Primary education and Female students (as % of total students) in Tertiary education?
Provide a short and direct response. -0.7. In the year 1976, what is the difference between the Female students (as % of total students) of Primary education and Female students (as % of total students) of Secondary general education?
Make the answer very short. -0.44. In the year 1976, what is the difference between the Female students (as % of total students) in Primary education and Female students (as % of total students) in Secondary vocational education?
Your response must be concise. 10.74. In the year 1976, what is the difference between the Female students (as % of total students) in Tertiary education and Female students (as % of total students) in Secondary general education?
Provide a succinct answer. 0.26. In the year 1976, what is the difference between the Female students (as % of total students) in Tertiary education and Female students (as % of total students) in Secondary vocational education?
Offer a very short reply. 11.44. In the year 1976, what is the difference between the Female students (as % of total students) of Secondary general education and Female students (as % of total students) of Secondary vocational education?
Provide a short and direct response. 11.18. In the year 1977, what is the difference between the Female students (as % of total students) of Primary education and Female students (as % of total students) of Tertiary education?
Keep it short and to the point. -1.02. In the year 1977, what is the difference between the Female students (as % of total students) of Primary education and Female students (as % of total students) of Secondary general education?
Ensure brevity in your answer.  -1.47. In the year 1977, what is the difference between the Female students (as % of total students) in Primary education and Female students (as % of total students) in Secondary vocational education?
Make the answer very short. 11.7. In the year 1977, what is the difference between the Female students (as % of total students) in Tertiary education and Female students (as % of total students) in Secondary general education?
Your answer should be compact. -0.45. In the year 1977, what is the difference between the Female students (as % of total students) of Tertiary education and Female students (as % of total students) of Secondary vocational education?
Your answer should be compact. 12.72. In the year 1977, what is the difference between the Female students (as % of total students) in Secondary general education and Female students (as % of total students) in Secondary vocational education?
Your answer should be compact. 13.17. What is the ratio of the Female students (as % of total students) in Tertiary education in 1971 to that in 1972?
Your answer should be very brief. 1.01. What is the ratio of the Female students (as % of total students) of Secondary vocational education in 1971 to that in 1972?
Provide a succinct answer. 1.09. What is the ratio of the Female students (as % of total students) of Primary education in 1971 to that in 1973?
Give a very brief answer. 1. What is the ratio of the Female students (as % of total students) of Secondary general education in 1971 to that in 1973?
Provide a short and direct response. 1. What is the ratio of the Female students (as % of total students) of Secondary vocational education in 1971 to that in 1973?
Your response must be concise. 0.95. What is the ratio of the Female students (as % of total students) in Tertiary education in 1971 to that in 1974?
Offer a terse response. 1.02. What is the ratio of the Female students (as % of total students) in Secondary general education in 1971 to that in 1974?
Your answer should be compact. 1.02. What is the ratio of the Female students (as % of total students) of Secondary vocational education in 1971 to that in 1974?
Provide a succinct answer. 0.93. What is the ratio of the Female students (as % of total students) in Tertiary education in 1971 to that in 1975?
Provide a short and direct response. 1.03. What is the ratio of the Female students (as % of total students) of Secondary general education in 1971 to that in 1975?
Provide a short and direct response. 1.06. What is the ratio of the Female students (as % of total students) of Secondary vocational education in 1971 to that in 1975?
Give a very brief answer. 0.8. What is the ratio of the Female students (as % of total students) of Tertiary education in 1971 to that in 1976?
Offer a very short reply. 1.03. What is the ratio of the Female students (as % of total students) in Secondary general education in 1971 to that in 1976?
Ensure brevity in your answer.  1.06. What is the ratio of the Female students (as % of total students) of Secondary vocational education in 1971 to that in 1976?
Provide a succinct answer. 0.75. What is the ratio of the Female students (as % of total students) of Tertiary education in 1971 to that in 1977?
Your response must be concise. 1.03. What is the ratio of the Female students (as % of total students) in Secondary general education in 1971 to that in 1977?
Make the answer very short. 1.04. What is the ratio of the Female students (as % of total students) in Secondary vocational education in 1971 to that in 1977?
Keep it short and to the point. 0.78. What is the ratio of the Female students (as % of total students) of Tertiary education in 1972 to that in 1973?
Provide a short and direct response. 0.99. What is the ratio of the Female students (as % of total students) of Secondary general education in 1972 to that in 1973?
Your response must be concise. 0.99. What is the ratio of the Female students (as % of total students) of Secondary vocational education in 1972 to that in 1973?
Provide a short and direct response. 0.87. What is the ratio of the Female students (as % of total students) of Tertiary education in 1972 to that in 1974?
Your answer should be very brief. 1.02. What is the ratio of the Female students (as % of total students) of Secondary general education in 1972 to that in 1974?
Provide a succinct answer. 1.02. What is the ratio of the Female students (as % of total students) of Secondary vocational education in 1972 to that in 1974?
Make the answer very short. 0.86. What is the ratio of the Female students (as % of total students) in Primary education in 1972 to that in 1975?
Keep it short and to the point. 0.99. What is the ratio of the Female students (as % of total students) of Tertiary education in 1972 to that in 1975?
Offer a terse response. 1.02. What is the ratio of the Female students (as % of total students) of Secondary general education in 1972 to that in 1975?
Make the answer very short. 1.06. What is the ratio of the Female students (as % of total students) of Secondary vocational education in 1972 to that in 1975?
Offer a very short reply. 0.74. What is the ratio of the Female students (as % of total students) in Primary education in 1972 to that in 1976?
Your response must be concise. 0.99. What is the ratio of the Female students (as % of total students) in Tertiary education in 1972 to that in 1976?
Your answer should be very brief. 1.02. What is the ratio of the Female students (as % of total students) of Secondary general education in 1972 to that in 1976?
Offer a very short reply. 1.05. What is the ratio of the Female students (as % of total students) in Secondary vocational education in 1972 to that in 1976?
Provide a short and direct response. 0.69. What is the ratio of the Female students (as % of total students) in Primary education in 1972 to that in 1977?
Your answer should be very brief. 0.99. What is the ratio of the Female students (as % of total students) in Secondary general education in 1972 to that in 1977?
Provide a short and direct response. 1.04. What is the ratio of the Female students (as % of total students) of Secondary vocational education in 1972 to that in 1977?
Your response must be concise. 0.71. What is the ratio of the Female students (as % of total students) of Tertiary education in 1973 to that in 1974?
Your answer should be compact. 1.03. What is the ratio of the Female students (as % of total students) in Secondary general education in 1973 to that in 1974?
Make the answer very short. 1.02. What is the ratio of the Female students (as % of total students) in Secondary vocational education in 1973 to that in 1974?
Keep it short and to the point. 0.99. What is the ratio of the Female students (as % of total students) of Tertiary education in 1973 to that in 1975?
Provide a short and direct response. 1.03. What is the ratio of the Female students (as % of total students) of Secondary general education in 1973 to that in 1975?
Provide a short and direct response. 1.07. What is the ratio of the Female students (as % of total students) in Secondary vocational education in 1973 to that in 1975?
Your answer should be very brief. 0.85. What is the ratio of the Female students (as % of total students) of Tertiary education in 1973 to that in 1976?
Your answer should be compact. 1.03. What is the ratio of the Female students (as % of total students) in Secondary general education in 1973 to that in 1976?
Provide a succinct answer. 1.06. What is the ratio of the Female students (as % of total students) of Secondary vocational education in 1973 to that in 1976?
Give a very brief answer. 0.79. What is the ratio of the Female students (as % of total students) of Primary education in 1973 to that in 1977?
Ensure brevity in your answer.  1. What is the ratio of the Female students (as % of total students) in Tertiary education in 1973 to that in 1977?
Provide a short and direct response. 1.03. What is the ratio of the Female students (as % of total students) of Secondary general education in 1973 to that in 1977?
Keep it short and to the point. 1.05. What is the ratio of the Female students (as % of total students) in Secondary vocational education in 1973 to that in 1977?
Your answer should be very brief. 0.82. What is the ratio of the Female students (as % of total students) of Secondary general education in 1974 to that in 1975?
Your answer should be compact. 1.04. What is the ratio of the Female students (as % of total students) in Secondary vocational education in 1974 to that in 1975?
Provide a short and direct response. 0.86. What is the ratio of the Female students (as % of total students) of Primary education in 1974 to that in 1976?
Keep it short and to the point. 0.99. What is the ratio of the Female students (as % of total students) of Secondary general education in 1974 to that in 1976?
Provide a succinct answer. 1.04. What is the ratio of the Female students (as % of total students) in Secondary vocational education in 1974 to that in 1976?
Ensure brevity in your answer.  0.8. What is the ratio of the Female students (as % of total students) of Primary education in 1974 to that in 1977?
Offer a very short reply. 1. What is the ratio of the Female students (as % of total students) in Secondary general education in 1974 to that in 1977?
Offer a very short reply. 1.02. What is the ratio of the Female students (as % of total students) in Secondary vocational education in 1974 to that in 1977?
Your answer should be compact. 0.83. What is the ratio of the Female students (as % of total students) of Secondary general education in 1975 to that in 1976?
Offer a very short reply. 0.99. What is the ratio of the Female students (as % of total students) in Secondary vocational education in 1975 to that in 1976?
Your answer should be very brief. 0.93. What is the ratio of the Female students (as % of total students) in Primary education in 1975 to that in 1977?
Give a very brief answer. 1. What is the ratio of the Female students (as % of total students) of Secondary general education in 1975 to that in 1977?
Provide a succinct answer. 0.98. What is the ratio of the Female students (as % of total students) in Secondary vocational education in 1975 to that in 1977?
Offer a terse response. 0.96. What is the ratio of the Female students (as % of total students) in Primary education in 1976 to that in 1977?
Provide a succinct answer. 1.01. What is the ratio of the Female students (as % of total students) in Tertiary education in 1976 to that in 1977?
Provide a succinct answer. 1. What is the ratio of the Female students (as % of total students) in Secondary general education in 1976 to that in 1977?
Ensure brevity in your answer.  0.99. What is the ratio of the Female students (as % of total students) in Secondary vocational education in 1976 to that in 1977?
Offer a terse response. 1.03. What is the difference between the highest and the second highest Female students (as % of total students) in Primary education?
Offer a very short reply. 0.23. What is the difference between the highest and the second highest Female students (as % of total students) of Tertiary education?
Give a very brief answer. 0.26. What is the difference between the highest and the second highest Female students (as % of total students) in Secondary general education?
Provide a succinct answer. 0.12. What is the difference between the highest and the second highest Female students (as % of total students) of Secondary vocational education?
Offer a terse response. 1.28. What is the difference between the highest and the lowest Female students (as % of total students) of Primary education?
Offer a terse response. 0.58. What is the difference between the highest and the lowest Female students (as % of total students) of Tertiary education?
Provide a short and direct response. 1.7. What is the difference between the highest and the lowest Female students (as % of total students) in Secondary general education?
Make the answer very short. 3.34. What is the difference between the highest and the lowest Female students (as % of total students) in Secondary vocational education?
Your answer should be very brief. 12.16. 